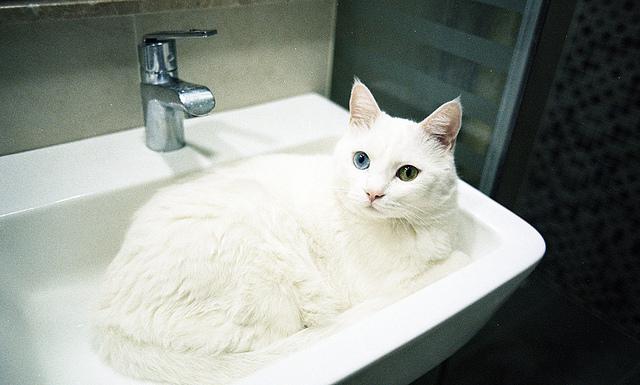Is this cat more prone to get cancer than the average cat?
Give a very brief answer. No. What is the cat laying in?
Concise answer only. Sink. What is the most unusual feature of this cat?
Be succinct. Eyes. 